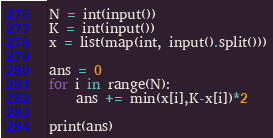Convert code to text. <code><loc_0><loc_0><loc_500><loc_500><_Python_>N = int(input())
K = int(input())
x = list(map(int, input().split()))

ans = 0
for i in range(N):
    ans += min(x[i],K-x[i])*2

print(ans)
</code> 